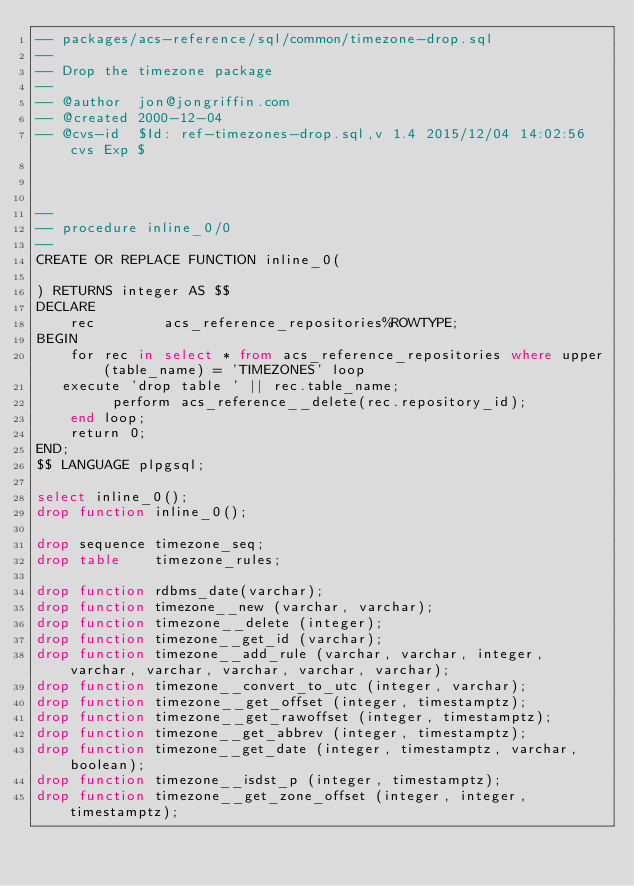Convert code to text. <code><loc_0><loc_0><loc_500><loc_500><_SQL_>-- packages/acs-reference/sql/common/timezone-drop.sql
--
-- Drop the timezone package
--
-- @author  jon@jongriffin.com
-- @created 2000-12-04
-- @cvs-id  $Id: ref-timezones-drop.sql,v 1.4 2015/12/04 14:02:56 cvs Exp $



--
-- procedure inline_0/0
--
CREATE OR REPLACE FUNCTION inline_0(

) RETURNS integer AS $$
DECLARE
    rec        acs_reference_repositories%ROWTYPE;
BEGIN
    for rec in select * from acs_reference_repositories where upper(table_name) = 'TIMEZONES' loop
	 execute 'drop table ' || rec.table_name;
         perform acs_reference__delete(rec.repository_id);
    end loop;
    return 0;
END;
$$ LANGUAGE plpgsql;

select inline_0();
drop function inline_0();

drop sequence timezone_seq;
drop table    timezone_rules;

drop function rdbms_date(varchar);
drop function timezone__new (varchar, varchar);
drop function timezone__delete (integer);
drop function timezone__get_id (varchar);
drop function timezone__add_rule (varchar, varchar, integer, varchar, varchar, varchar, varchar, varchar);
drop function timezone__convert_to_utc (integer, varchar);
drop function timezone__get_offset (integer, timestamptz);
drop function timezone__get_rawoffset (integer, timestamptz);
drop function timezone__get_abbrev (integer, timestamptz);
drop function timezone__get_date (integer, timestamptz, varchar, boolean);
drop function timezone__isdst_p (integer, timestamptz);
drop function timezone__get_zone_offset (integer, integer, timestamptz);
</code> 